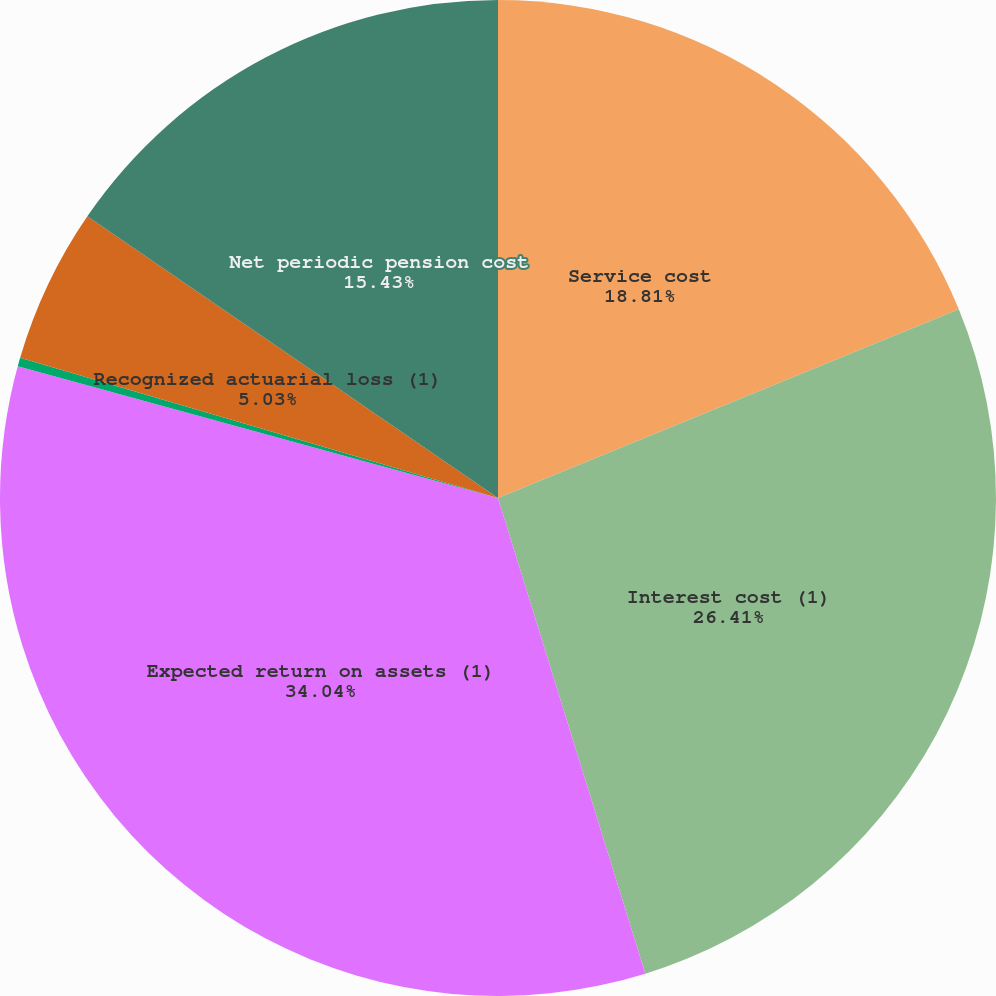<chart> <loc_0><loc_0><loc_500><loc_500><pie_chart><fcel>Service cost<fcel>Interest cost (1)<fcel>Expected return on assets (1)<fcel>Amortization of prior service<fcel>Recognized actuarial loss (1)<fcel>Net periodic pension cost<nl><fcel>18.81%<fcel>26.41%<fcel>34.04%<fcel>0.28%<fcel>5.03%<fcel>15.43%<nl></chart> 